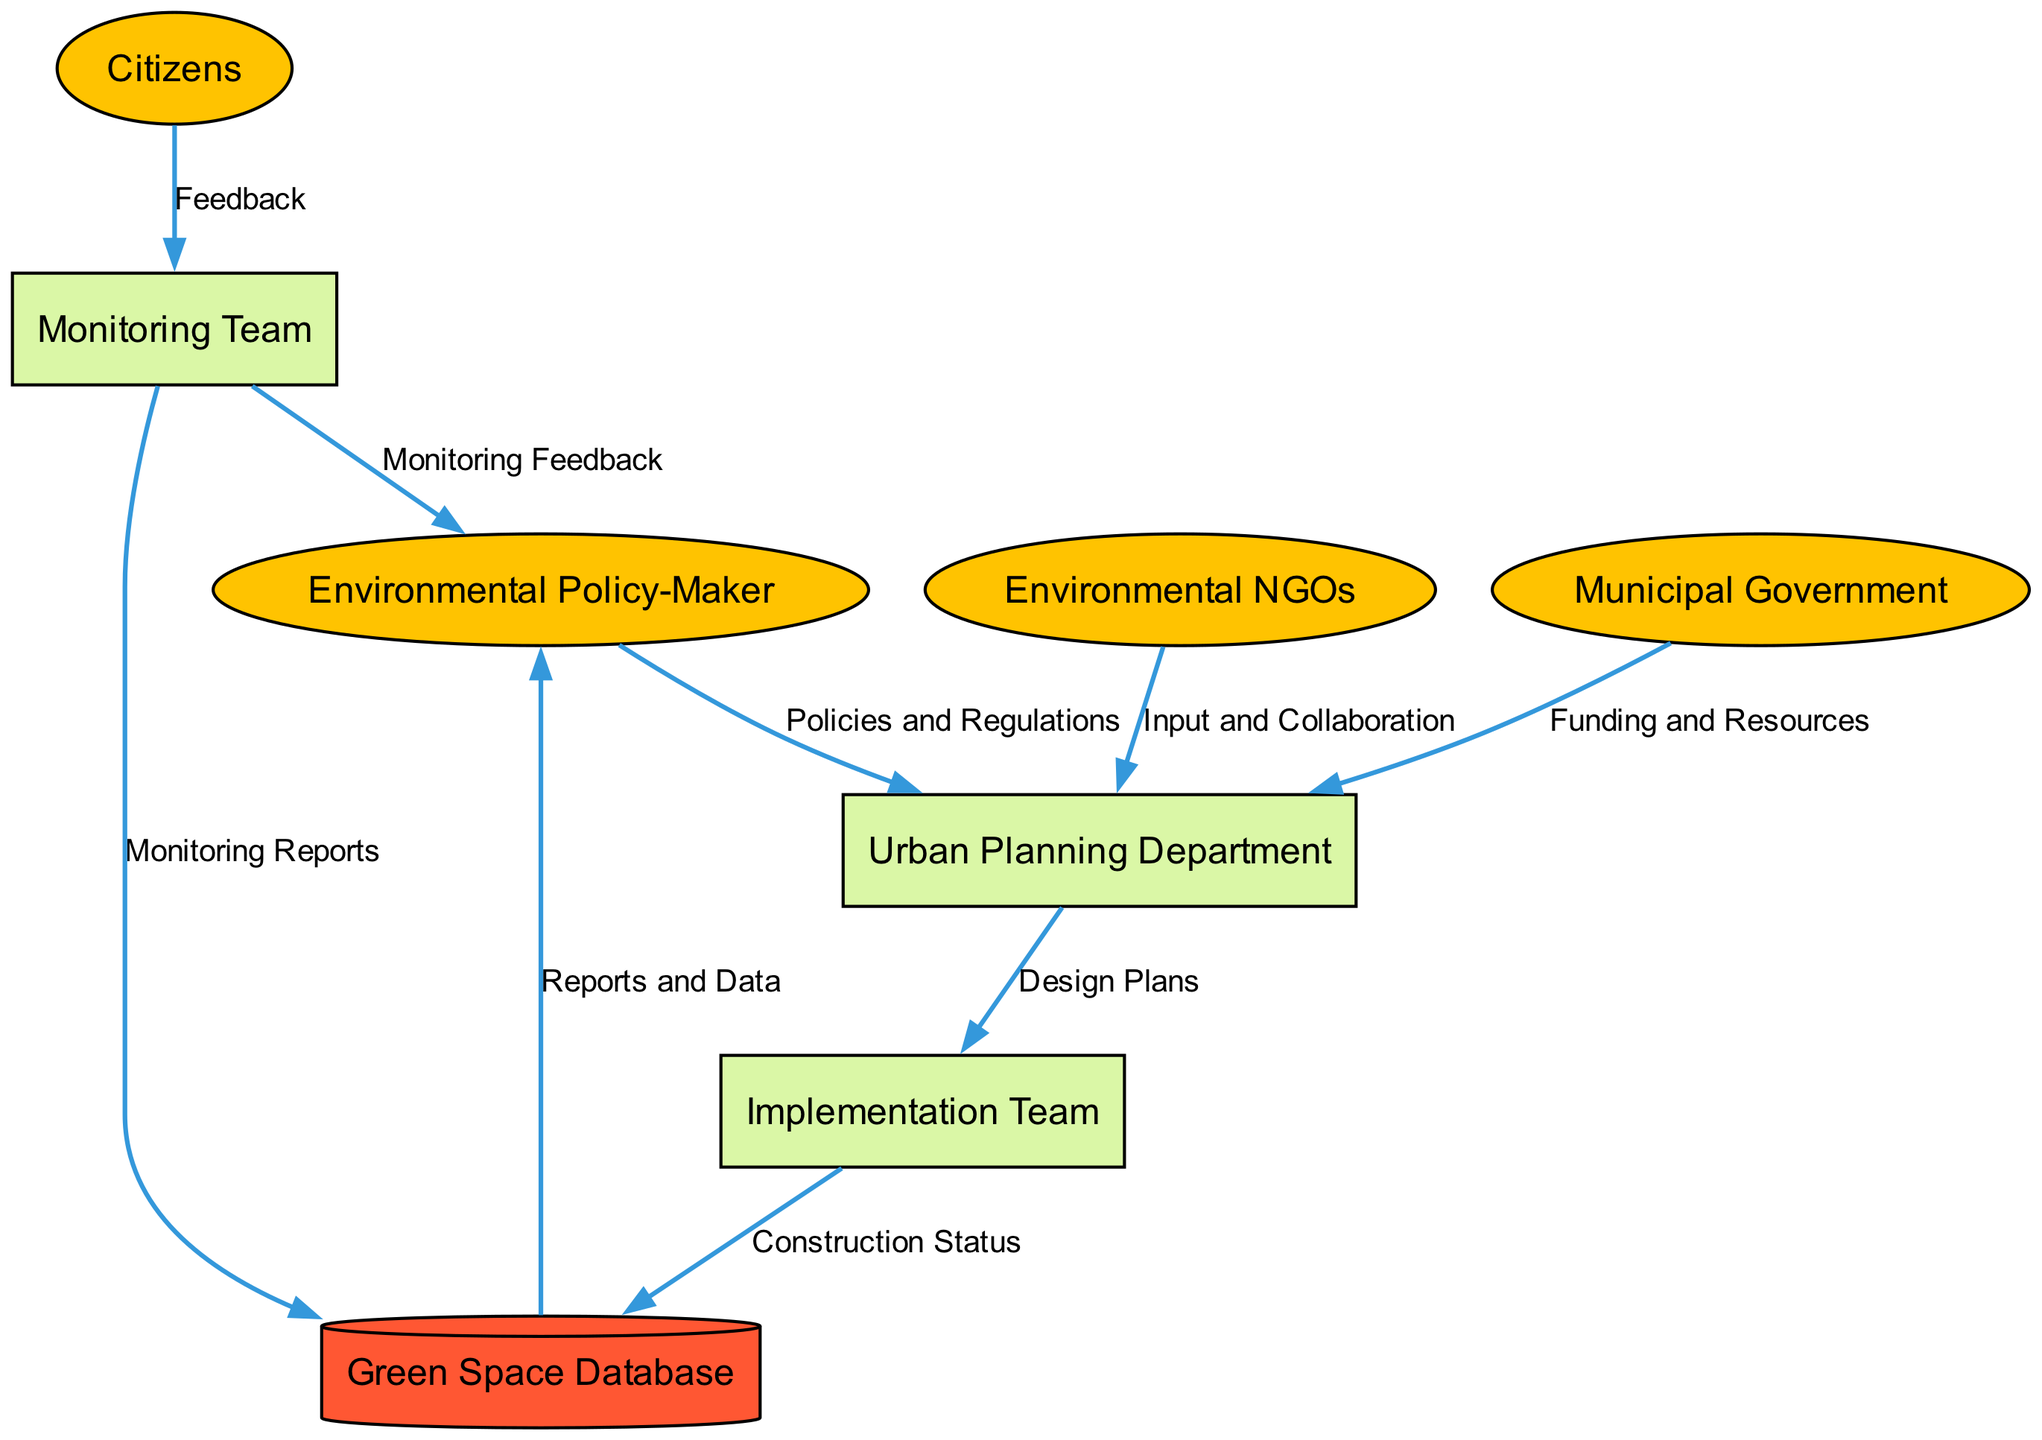What is the primary role of the Environmental Policy-Maker? The Environmental Policy-Maker decides on policies and regulations related to urban green spaces, as indicated in the diagram.
Answer: Decides on policies and regulations How many external entities are represented in the diagram? There are four external entities: Environmental Policy-Maker, Municipal Government, Environmental NGOs, and Citizens, as seen in the diagram.
Answer: Four What flow does the Municipal Government provide to the Urban Planning Department? The Municipal Government provides funding and resources to the Urban Planning Department, as shown in the data flow.
Answer: Funding and Resources Which process is responsible for constructing and maintaining green spaces? The Implementation Team is responsible for constructing and maintaining green spaces, according to the diagram.
Answer: Implementation Team What type of data is stored in the Green Space Database? The Green Space Database stores information on location, size, condition, and usage of urban green spaces, as noted in the diagram.
Answer: Location, size, condition, and usage What feedback do Citizens provide to the Monitoring Team? Citizens provide feedback to the Monitoring Team, which is a direct flow depicted in the diagram.
Answer: Feedback Which team assesses and reports the condition and usage of green spaces? The Monitoring Team assesses and reports the condition and usage of green spaces, as identified in the diagram.
Answer: Monitoring Team How do Environmental NGOs interact with the Urban Planning Department? Environmental NGOs provide input and collaboration to the Urban Planning Department, which is outlined in the data flow.
Answer: Input and Collaboration What does the Monitoring Team send to the Green Space Database? The Monitoring Team sends monitoring reports to the Green Space Database, as indicated in the data flow.
Answer: Monitoring Reports 